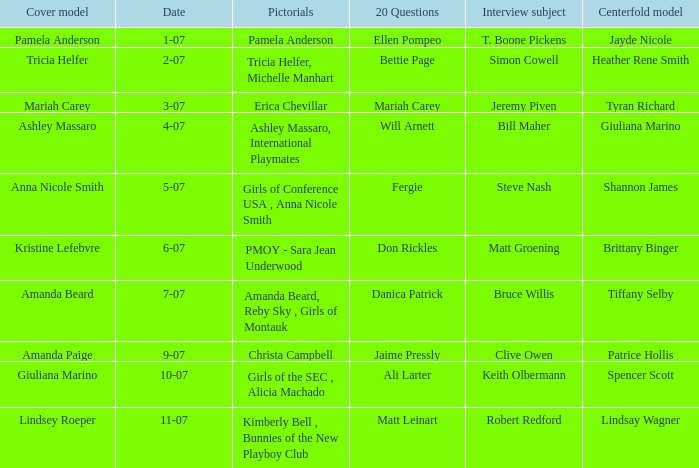Who was the centerfold model when the issue's pictorial was kimberly bell , bunnies of the new playboy club? Lindsay Wagner. 